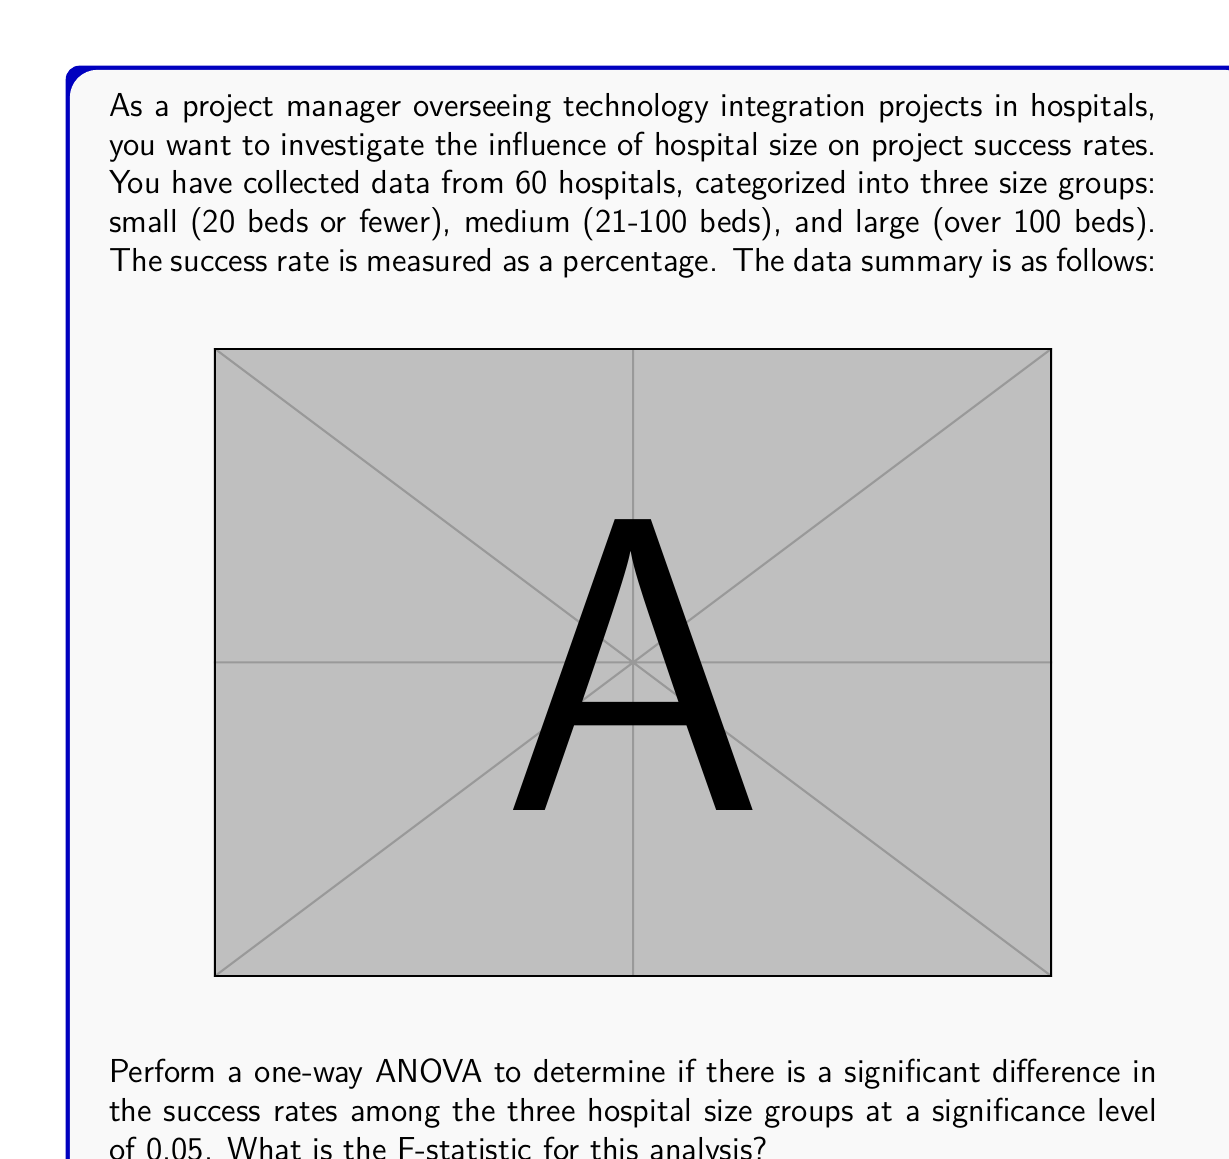Solve this math problem. To perform a one-way ANOVA, we need to follow these steps:

1) Calculate the mean for each group and the overall mean:
   Small: $\bar{X}_1 = \frac{70+75+80+72+78}{5} = 75$
   Medium: $\bar{X}_2 = \frac{82+85+79+81+83}{5} = 82$
   Large: $\bar{X}_3 = \frac{88+90+87+92+89}{5} = 89.2$
   Overall: $\bar{X} = \frac{75+82+89.2}{3} = 82.07$

2) Calculate the Sum of Squares Between groups (SSB):
   $$SSB = \sum_{i=1}^{k} n_i(\bar{X}_i - \bar{X})^2$$
   $$SSB = 5(75-82.07)^2 + 5(82-82.07)^2 + 5(89.2-82.07)^2 = 612.13$$

3) Calculate the Sum of Squares Within groups (SSW):
   $$SSW = \sum_{i=1}^{k} \sum_{j=1}^{n_i} (X_{ij} - \bar{X}_i)^2$$
   $$SSW = [(70-75)^2 + ... + (78-75)^2] + [(82-82)^2 + ... + (83-82)^2] + [(88-89.2)^2 + ... + (89-89.2)^2] = 280$$

4) Calculate the degrees of freedom:
   Between groups: $df_B = k - 1 = 3 - 1 = 2$
   Within groups: $df_W = N - k = 15 - 3 = 12$

5) Calculate the Mean Square Between (MSB) and Mean Square Within (MSW):
   $$MSB = \frac{SSB}{df_B} = \frac{612.13}{2} = 306.065$$
   $$MSW = \frac{SSW}{df_W} = \frac{280}{12} = 23.33$$

6) Calculate the F-statistic:
   $$F = \frac{MSB}{MSW} = \frac{306.065}{23.33} = 13.12$$

Therefore, the F-statistic for this analysis is 13.12.
Answer: 13.12 